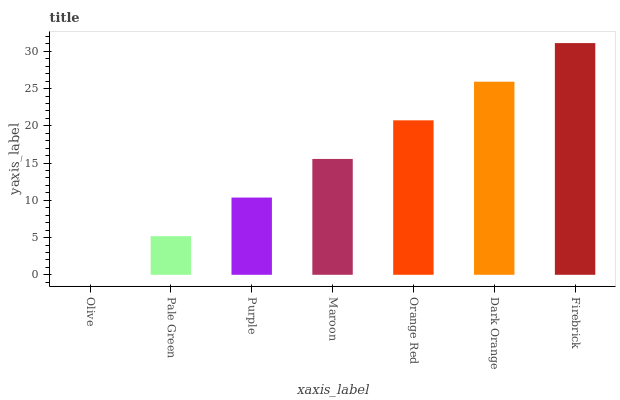Is Olive the minimum?
Answer yes or no. Yes. Is Firebrick the maximum?
Answer yes or no. Yes. Is Pale Green the minimum?
Answer yes or no. No. Is Pale Green the maximum?
Answer yes or no. No. Is Pale Green greater than Olive?
Answer yes or no. Yes. Is Olive less than Pale Green?
Answer yes or no. Yes. Is Olive greater than Pale Green?
Answer yes or no. No. Is Pale Green less than Olive?
Answer yes or no. No. Is Maroon the high median?
Answer yes or no. Yes. Is Maroon the low median?
Answer yes or no. Yes. Is Olive the high median?
Answer yes or no. No. Is Orange Red the low median?
Answer yes or no. No. 